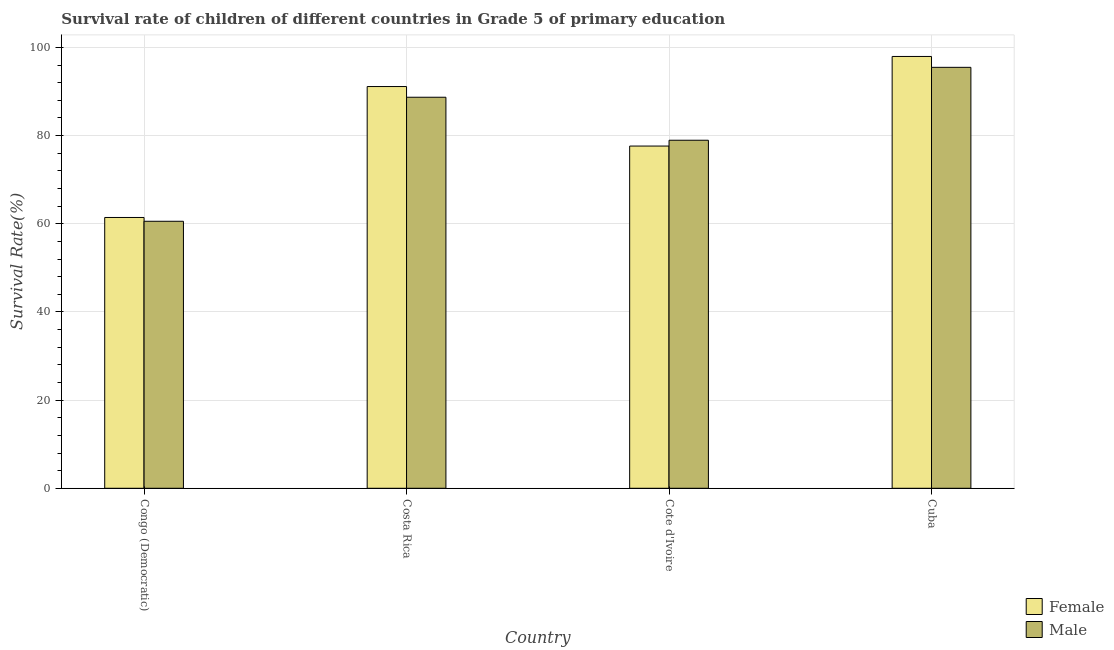Are the number of bars per tick equal to the number of legend labels?
Provide a succinct answer. Yes. What is the label of the 2nd group of bars from the left?
Offer a terse response. Costa Rica. In how many cases, is the number of bars for a given country not equal to the number of legend labels?
Offer a very short reply. 0. What is the survival rate of female students in primary education in Costa Rica?
Your answer should be compact. 91.13. Across all countries, what is the maximum survival rate of female students in primary education?
Provide a succinct answer. 97.95. Across all countries, what is the minimum survival rate of female students in primary education?
Offer a very short reply. 61.43. In which country was the survival rate of female students in primary education maximum?
Your response must be concise. Cuba. In which country was the survival rate of male students in primary education minimum?
Your response must be concise. Congo (Democratic). What is the total survival rate of female students in primary education in the graph?
Give a very brief answer. 328.14. What is the difference between the survival rate of female students in primary education in Congo (Democratic) and that in Costa Rica?
Keep it short and to the point. -29.7. What is the difference between the survival rate of male students in primary education in Cuba and the survival rate of female students in primary education in Congo (Democratic)?
Provide a short and direct response. 34.06. What is the average survival rate of male students in primary education per country?
Provide a succinct answer. 80.93. What is the difference between the survival rate of male students in primary education and survival rate of female students in primary education in Cuba?
Offer a very short reply. -2.47. In how many countries, is the survival rate of male students in primary education greater than 4 %?
Ensure brevity in your answer.  4. What is the ratio of the survival rate of female students in primary education in Costa Rica to that in Cuba?
Your answer should be very brief. 0.93. Is the survival rate of male students in primary education in Congo (Democratic) less than that in Costa Rica?
Ensure brevity in your answer.  Yes. Is the difference between the survival rate of female students in primary education in Congo (Democratic) and Cote d'Ivoire greater than the difference between the survival rate of male students in primary education in Congo (Democratic) and Cote d'Ivoire?
Your answer should be very brief. Yes. What is the difference between the highest and the second highest survival rate of male students in primary education?
Your answer should be very brief. 6.78. What is the difference between the highest and the lowest survival rate of male students in primary education?
Offer a terse response. 34.92. Is the sum of the survival rate of male students in primary education in Congo (Democratic) and Cote d'Ivoire greater than the maximum survival rate of female students in primary education across all countries?
Your response must be concise. Yes. What does the 1st bar from the left in Cuba represents?
Give a very brief answer. Female. Are all the bars in the graph horizontal?
Offer a terse response. No. How many countries are there in the graph?
Your answer should be compact. 4. What is the difference between two consecutive major ticks on the Y-axis?
Offer a terse response. 20. Are the values on the major ticks of Y-axis written in scientific E-notation?
Offer a terse response. No. Does the graph contain any zero values?
Make the answer very short. No. Does the graph contain grids?
Keep it short and to the point. Yes. What is the title of the graph?
Provide a succinct answer. Survival rate of children of different countries in Grade 5 of primary education. Does "Number of arrivals" appear as one of the legend labels in the graph?
Your answer should be very brief. No. What is the label or title of the X-axis?
Offer a very short reply. Country. What is the label or title of the Y-axis?
Give a very brief answer. Survival Rate(%). What is the Survival Rate(%) in Female in Congo (Democratic)?
Your answer should be compact. 61.43. What is the Survival Rate(%) of Male in Congo (Democratic)?
Keep it short and to the point. 60.57. What is the Survival Rate(%) in Female in Costa Rica?
Keep it short and to the point. 91.13. What is the Survival Rate(%) in Male in Costa Rica?
Your answer should be compact. 88.7. What is the Survival Rate(%) in Female in Cote d'Ivoire?
Give a very brief answer. 77.63. What is the Survival Rate(%) in Male in Cote d'Ivoire?
Your answer should be very brief. 78.95. What is the Survival Rate(%) of Female in Cuba?
Ensure brevity in your answer.  97.95. What is the Survival Rate(%) of Male in Cuba?
Provide a succinct answer. 95.49. Across all countries, what is the maximum Survival Rate(%) in Female?
Keep it short and to the point. 97.95. Across all countries, what is the maximum Survival Rate(%) of Male?
Make the answer very short. 95.49. Across all countries, what is the minimum Survival Rate(%) of Female?
Your answer should be very brief. 61.43. Across all countries, what is the minimum Survival Rate(%) of Male?
Your answer should be very brief. 60.57. What is the total Survival Rate(%) of Female in the graph?
Your response must be concise. 328.14. What is the total Survival Rate(%) in Male in the graph?
Keep it short and to the point. 323.7. What is the difference between the Survival Rate(%) of Female in Congo (Democratic) and that in Costa Rica?
Provide a succinct answer. -29.7. What is the difference between the Survival Rate(%) of Male in Congo (Democratic) and that in Costa Rica?
Provide a short and direct response. -28.13. What is the difference between the Survival Rate(%) in Female in Congo (Democratic) and that in Cote d'Ivoire?
Offer a terse response. -16.2. What is the difference between the Survival Rate(%) in Male in Congo (Democratic) and that in Cote d'Ivoire?
Offer a terse response. -18.38. What is the difference between the Survival Rate(%) of Female in Congo (Democratic) and that in Cuba?
Make the answer very short. -36.53. What is the difference between the Survival Rate(%) of Male in Congo (Democratic) and that in Cuba?
Offer a very short reply. -34.92. What is the difference between the Survival Rate(%) in Female in Costa Rica and that in Cote d'Ivoire?
Make the answer very short. 13.5. What is the difference between the Survival Rate(%) in Male in Costa Rica and that in Cote d'Ivoire?
Ensure brevity in your answer.  9.75. What is the difference between the Survival Rate(%) in Female in Costa Rica and that in Cuba?
Offer a terse response. -6.82. What is the difference between the Survival Rate(%) in Male in Costa Rica and that in Cuba?
Keep it short and to the point. -6.78. What is the difference between the Survival Rate(%) in Female in Cote d'Ivoire and that in Cuba?
Offer a very short reply. -20.32. What is the difference between the Survival Rate(%) in Male in Cote d'Ivoire and that in Cuba?
Offer a terse response. -16.54. What is the difference between the Survival Rate(%) of Female in Congo (Democratic) and the Survival Rate(%) of Male in Costa Rica?
Provide a short and direct response. -27.27. What is the difference between the Survival Rate(%) of Female in Congo (Democratic) and the Survival Rate(%) of Male in Cote d'Ivoire?
Keep it short and to the point. -17.52. What is the difference between the Survival Rate(%) in Female in Congo (Democratic) and the Survival Rate(%) in Male in Cuba?
Provide a short and direct response. -34.06. What is the difference between the Survival Rate(%) in Female in Costa Rica and the Survival Rate(%) in Male in Cote d'Ivoire?
Give a very brief answer. 12.18. What is the difference between the Survival Rate(%) in Female in Costa Rica and the Survival Rate(%) in Male in Cuba?
Your response must be concise. -4.35. What is the difference between the Survival Rate(%) in Female in Cote d'Ivoire and the Survival Rate(%) in Male in Cuba?
Keep it short and to the point. -17.85. What is the average Survival Rate(%) in Female per country?
Make the answer very short. 82.04. What is the average Survival Rate(%) in Male per country?
Ensure brevity in your answer.  80.93. What is the difference between the Survival Rate(%) in Female and Survival Rate(%) in Male in Congo (Democratic)?
Give a very brief answer. 0.86. What is the difference between the Survival Rate(%) in Female and Survival Rate(%) in Male in Costa Rica?
Give a very brief answer. 2.43. What is the difference between the Survival Rate(%) of Female and Survival Rate(%) of Male in Cote d'Ivoire?
Keep it short and to the point. -1.32. What is the difference between the Survival Rate(%) in Female and Survival Rate(%) in Male in Cuba?
Provide a short and direct response. 2.47. What is the ratio of the Survival Rate(%) of Female in Congo (Democratic) to that in Costa Rica?
Keep it short and to the point. 0.67. What is the ratio of the Survival Rate(%) of Male in Congo (Democratic) to that in Costa Rica?
Keep it short and to the point. 0.68. What is the ratio of the Survival Rate(%) of Female in Congo (Democratic) to that in Cote d'Ivoire?
Keep it short and to the point. 0.79. What is the ratio of the Survival Rate(%) in Male in Congo (Democratic) to that in Cote d'Ivoire?
Make the answer very short. 0.77. What is the ratio of the Survival Rate(%) of Female in Congo (Democratic) to that in Cuba?
Your answer should be compact. 0.63. What is the ratio of the Survival Rate(%) in Male in Congo (Democratic) to that in Cuba?
Give a very brief answer. 0.63. What is the ratio of the Survival Rate(%) in Female in Costa Rica to that in Cote d'Ivoire?
Keep it short and to the point. 1.17. What is the ratio of the Survival Rate(%) of Male in Costa Rica to that in Cote d'Ivoire?
Keep it short and to the point. 1.12. What is the ratio of the Survival Rate(%) of Female in Costa Rica to that in Cuba?
Give a very brief answer. 0.93. What is the ratio of the Survival Rate(%) in Male in Costa Rica to that in Cuba?
Give a very brief answer. 0.93. What is the ratio of the Survival Rate(%) of Female in Cote d'Ivoire to that in Cuba?
Ensure brevity in your answer.  0.79. What is the ratio of the Survival Rate(%) in Male in Cote d'Ivoire to that in Cuba?
Provide a short and direct response. 0.83. What is the difference between the highest and the second highest Survival Rate(%) of Female?
Ensure brevity in your answer.  6.82. What is the difference between the highest and the second highest Survival Rate(%) in Male?
Provide a short and direct response. 6.78. What is the difference between the highest and the lowest Survival Rate(%) of Female?
Your answer should be very brief. 36.53. What is the difference between the highest and the lowest Survival Rate(%) in Male?
Offer a very short reply. 34.92. 